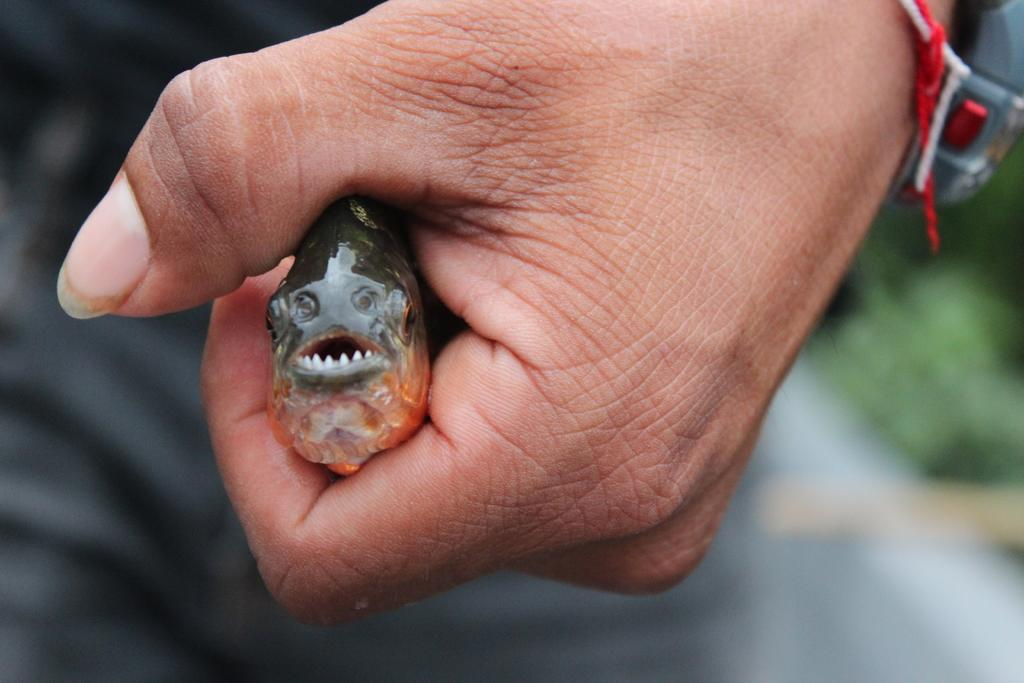Who or what is the main subject in the image? There is a person in the image. What is the person holding in the image? The person is holding fish. Can you describe the background of the image? The background of the image is blurry. What type of fireman equipment can be seen in the image? There is no fireman equipment present in the image. How many women are visible in the image? There is no mention of women in the provided facts, so we cannot determine the number of women in the image. 